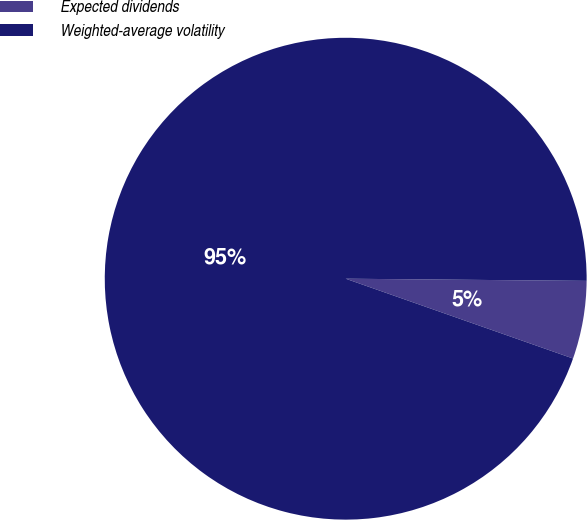<chart> <loc_0><loc_0><loc_500><loc_500><pie_chart><fcel>Expected dividends<fcel>Weighted-average volatility<nl><fcel>5.23%<fcel>94.77%<nl></chart> 